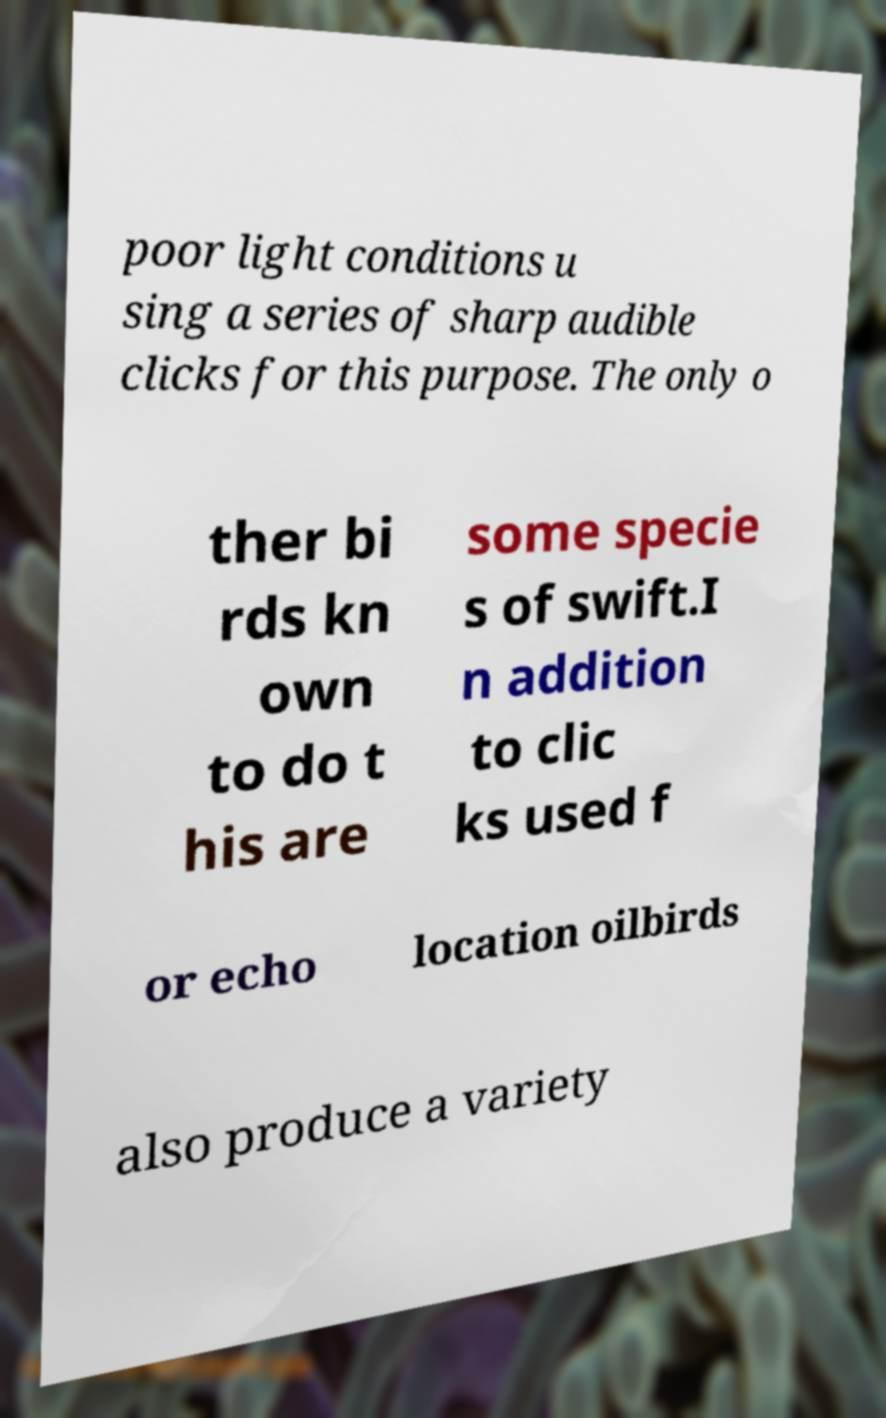Can you accurately transcribe the text from the provided image for me? poor light conditions u sing a series of sharp audible clicks for this purpose. The only o ther bi rds kn own to do t his are some specie s of swift.I n addition to clic ks used f or echo location oilbirds also produce a variety 